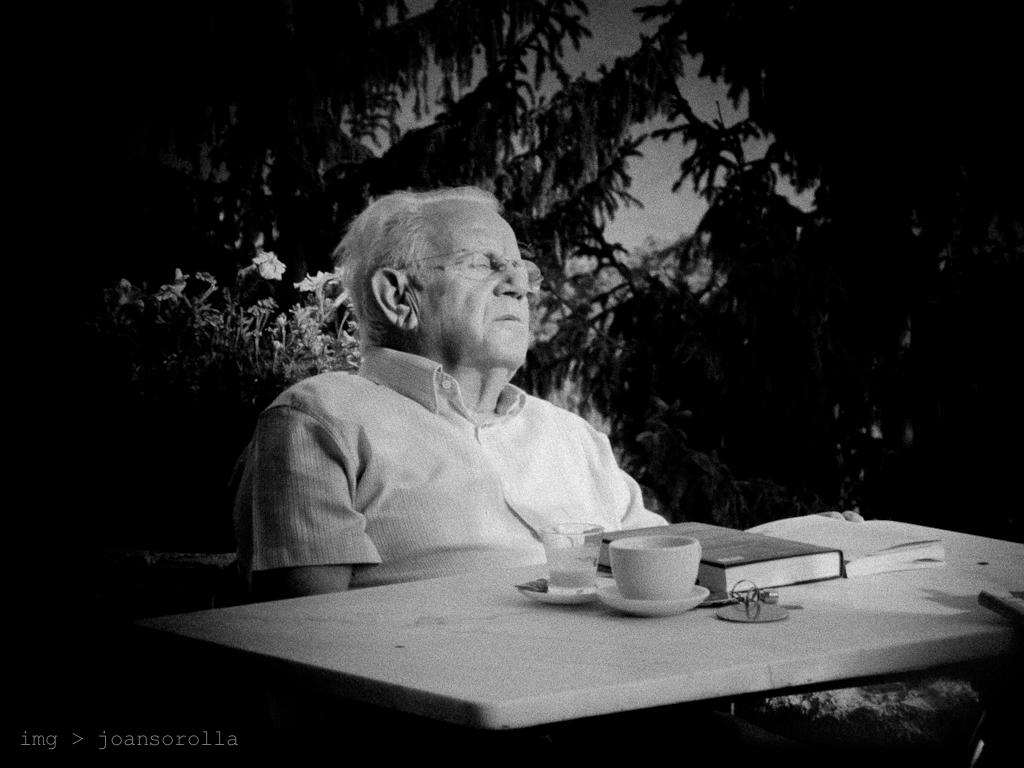What is the man in the image doing? The man is sitting in a chair. Where is the man located in relation to the table? The man is near a table. What items can be seen on the table? There is a cup, a saucer, a glass, and a book on the table. What is visible in the background of the image? There is a tree visible in the background. What type of vase can be seen on the table in the image? There is no vase present on the table in the image. What sound does the woman make in the image? There is no woman present in the image, so no sound can be attributed to her. 